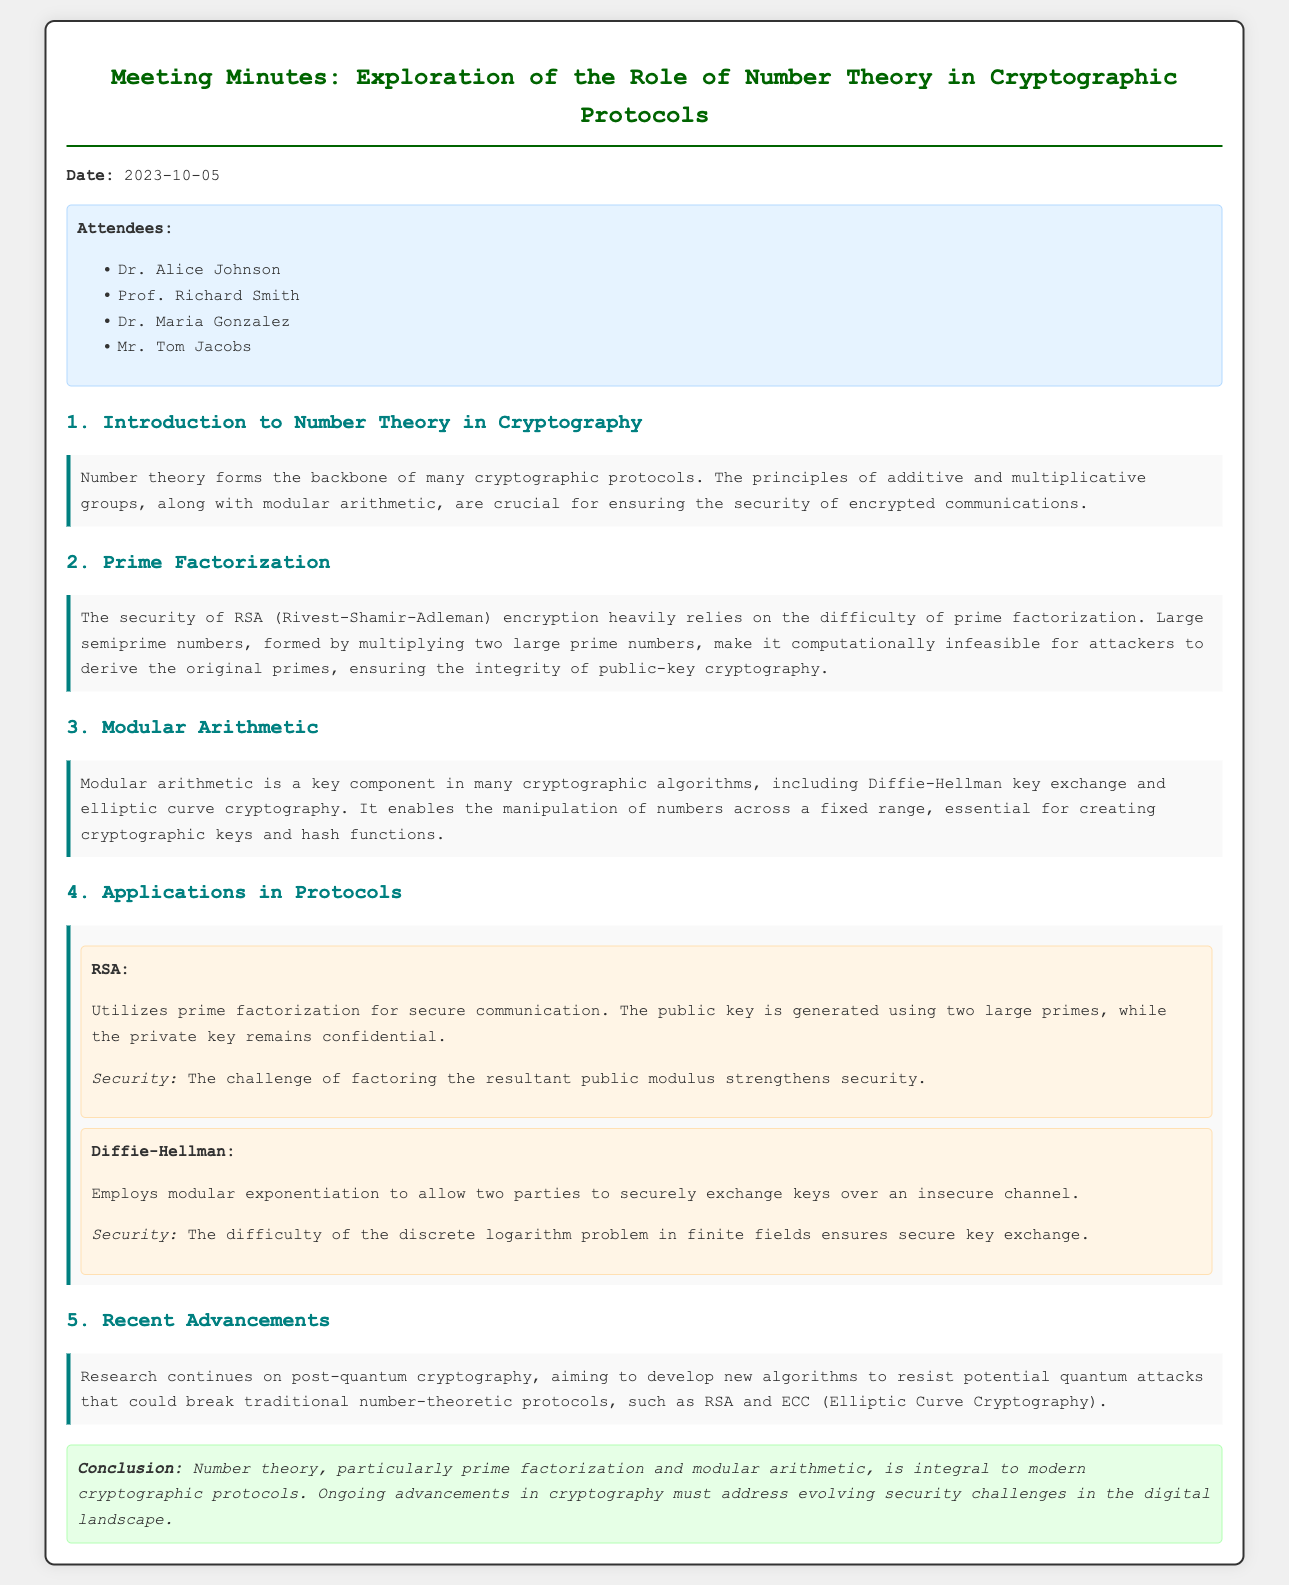What is the date of the meeting? The date of the meeting is stated at the top of the document.
Answer: 2023-10-05 Who attended the meeting? The document lists the attendees in a dedicated section, providing names.
Answer: Dr. Alice Johnson, Prof. Richard Smith, Dr. Maria Gonzalez, Mr. Tom Jacobs What cryptographic protocol is mentioned that relies on prime factorization? The key points section mentions RSA encryption specifically linked to prime factorization.
Answer: RSA What is a key component of Diffie-Hellman? The document explains that modular exponentiation is employed for key exchange.
Answer: Modular exponentiation What is a significant challenge mentioned in relation to RSA? The minutes indicate that the difficulty of factoring the resultant public modulus is a key challenge.
Answer: Factoring What ongoing research area is highlighted in the document? The document notes research on post-quantum cryptography concerning potential future security issues.
Answer: Post-quantum cryptography What mathematical field underpins many cryptographic protocols? The introduction section emphasizes number theory's foundational role in cryptography.
Answer: Number theory What does RSA stand for? The context implies that the abbreviation RSA is defined within the document.
Answer: Rivest-Shamir-Adleman 